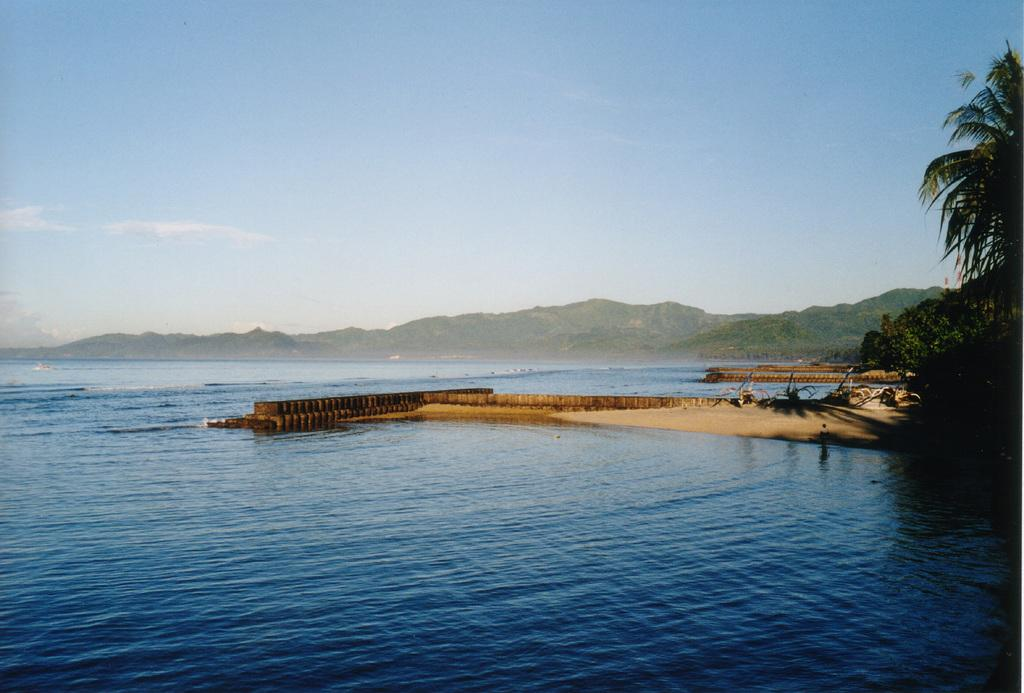What type of bridge is in the center of the image? There is a board bridge in the center of the image. What can be seen in the background of the image? There are trees and hills in the background of the image. What is visible at the bottom of the image? There is water visible at the bottom of the image. What is visible at the top of the image? The sky is visible at the top of the image. What type of pollution is present in the image? There is no indication of pollution in the image; it features a board bridge, trees, hills, water, and sky. What hobbies are being pursued by the trees in the image? Trees do not have hobbies, as they are inanimate objects. 